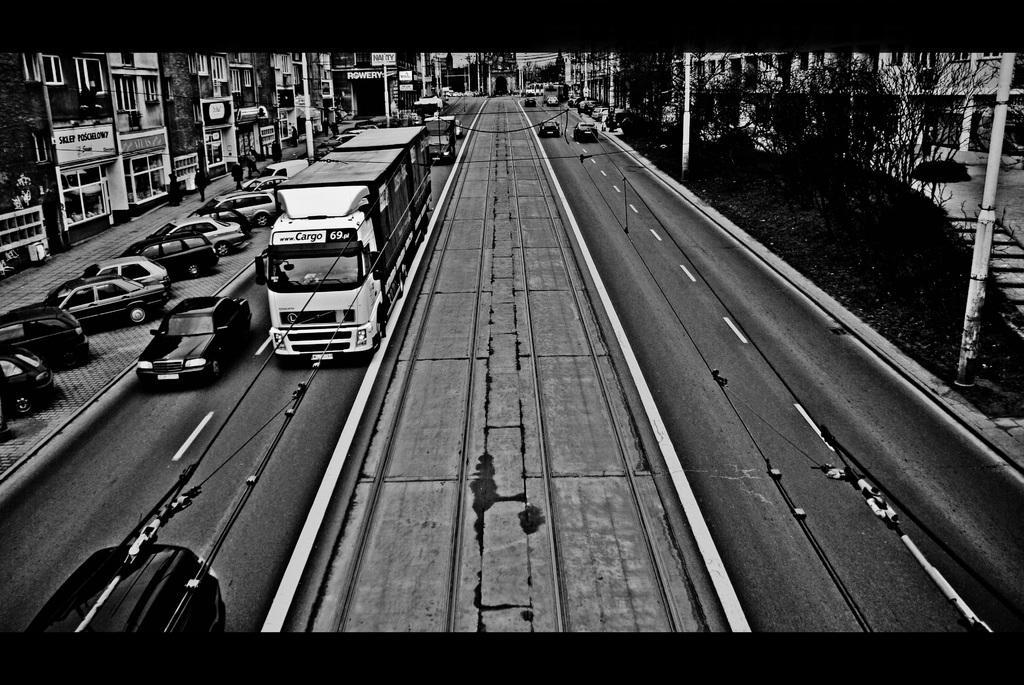How would you summarize this image in a sentence or two? A black and white picture of a city. Vehicles are travelling on a road. Cars are at parking area. There are number of buildings. Number of trees. Divider is in middle of the roads. 